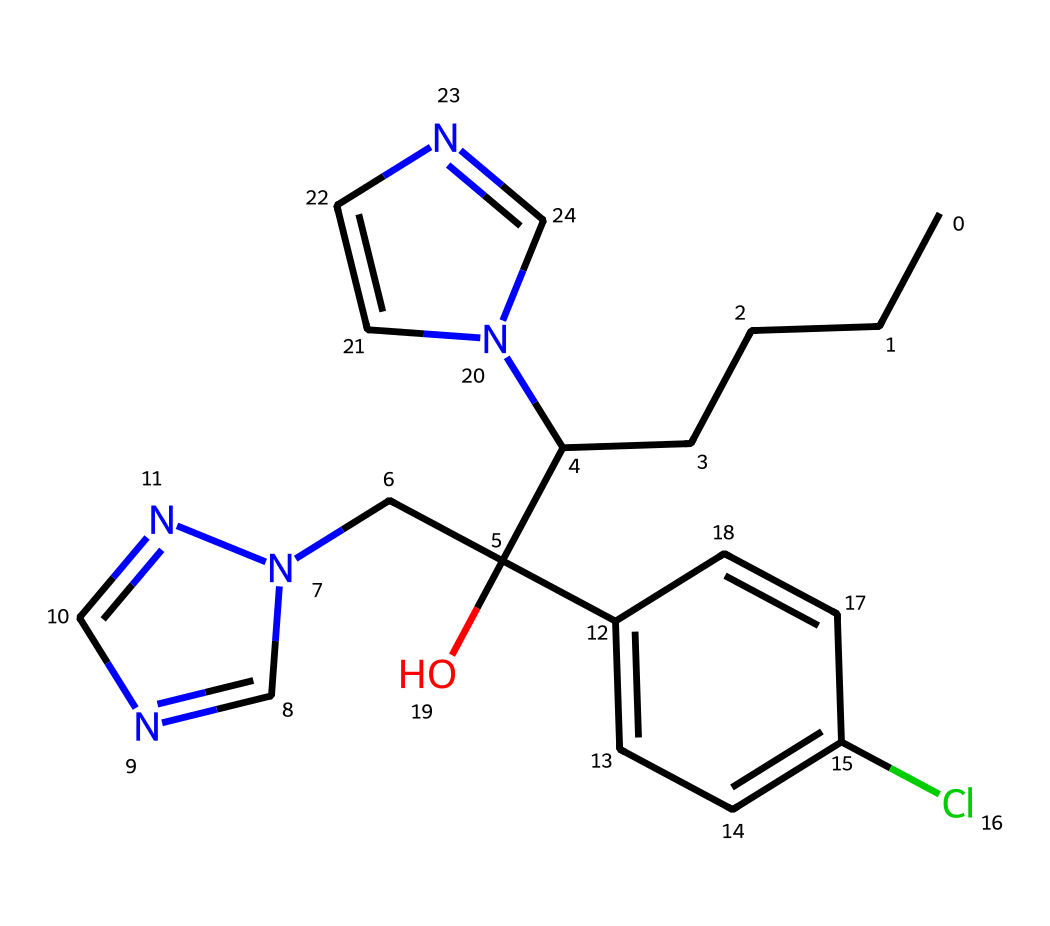How many nitrogen atoms are present in this chemical structure? By examining the SMILES representation, we identify the presence of nitrogen atoms in the molecular structure. There are two instances of 'n' that indicate the presence of nitrogen atoms in the structure. Counting them gives us a total of two nitrogen atoms.
Answer: two What is the main functional group of this chemical? Looking at the structure of the chemical in the SMILES representation, the 'O' indicates a hydroxyl group, which is a significant functional group in this compound. This is a key characteristic of alcohols, suggesting that the main functional group here is the hydroxyl group.
Answer: hydroxyl What is the molecular weight of propiconazole? The molecular weight can be calculated based on the atomic weights of each element represented in the compound. Counting from the SMILES reveals the following elements and their quantities: C (14), H (18), N (4), and Cl (1). Using atomic weights (C=12.01, H=1.01, N=14.01, Cl=35.45), the total molecular weight is calculated to be approximately 270.8 g/mol.
Answer: 270.8 Which type of chemical interaction is primarily targeted by propiconazole as a fungicide? Propiconazole acts primarily by inhibiting the biosynthesis of ergosterol, which is essential for fungal membrane integrity. This interaction disrupts fungal cell membranes, effectively killing or inhibiting the growth of fungi. Hence, it targets ergosterol biosynthesis.
Answer: ergosterol biosynthesis How does the presence of chlorine affect the properties of this fungicide? The presence of chlorine in the compound, as indicated by 'Cl' in the SMILES, enhances the potency of the fungicide and affects its lipophilicity, allowing better penetration and effectiveness. This halogen substitution tends to increase the compound's ability to engage in biological interaction with target sites.
Answer: increases potency What specific type of fungi is propiconazole known to be effective against? Propiconazole is known to be effective against various fungi, specifically including species of the genus Fusarium and Colletotrichum. Such species are commonly found in plant diseases and post-harvest rot. This makes the fungicide particularly useful in agricultural settings.
Answer: Fusarium, Colletotrichum What does the presence of multiple aromatic rings in the structure suggest about this chemical? The presence of multiple aromatic rings, as can be inferred from the 'C2=CC=' notation in the SMILES, suggests a stable configuration and potential for significant interaction with biological targets. Generally, compounds with aromatic systems exhibit hydrophobic characteristics beneficial for their fungicidal activity.
Answer: stability and hydrophobicity 